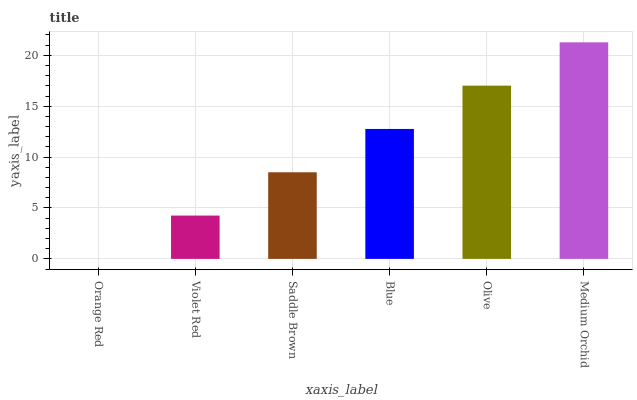Is Violet Red the minimum?
Answer yes or no. No. Is Violet Red the maximum?
Answer yes or no. No. Is Violet Red greater than Orange Red?
Answer yes or no. Yes. Is Orange Red less than Violet Red?
Answer yes or no. Yes. Is Orange Red greater than Violet Red?
Answer yes or no. No. Is Violet Red less than Orange Red?
Answer yes or no. No. Is Blue the high median?
Answer yes or no. Yes. Is Saddle Brown the low median?
Answer yes or no. Yes. Is Saddle Brown the high median?
Answer yes or no. No. Is Olive the low median?
Answer yes or no. No. 